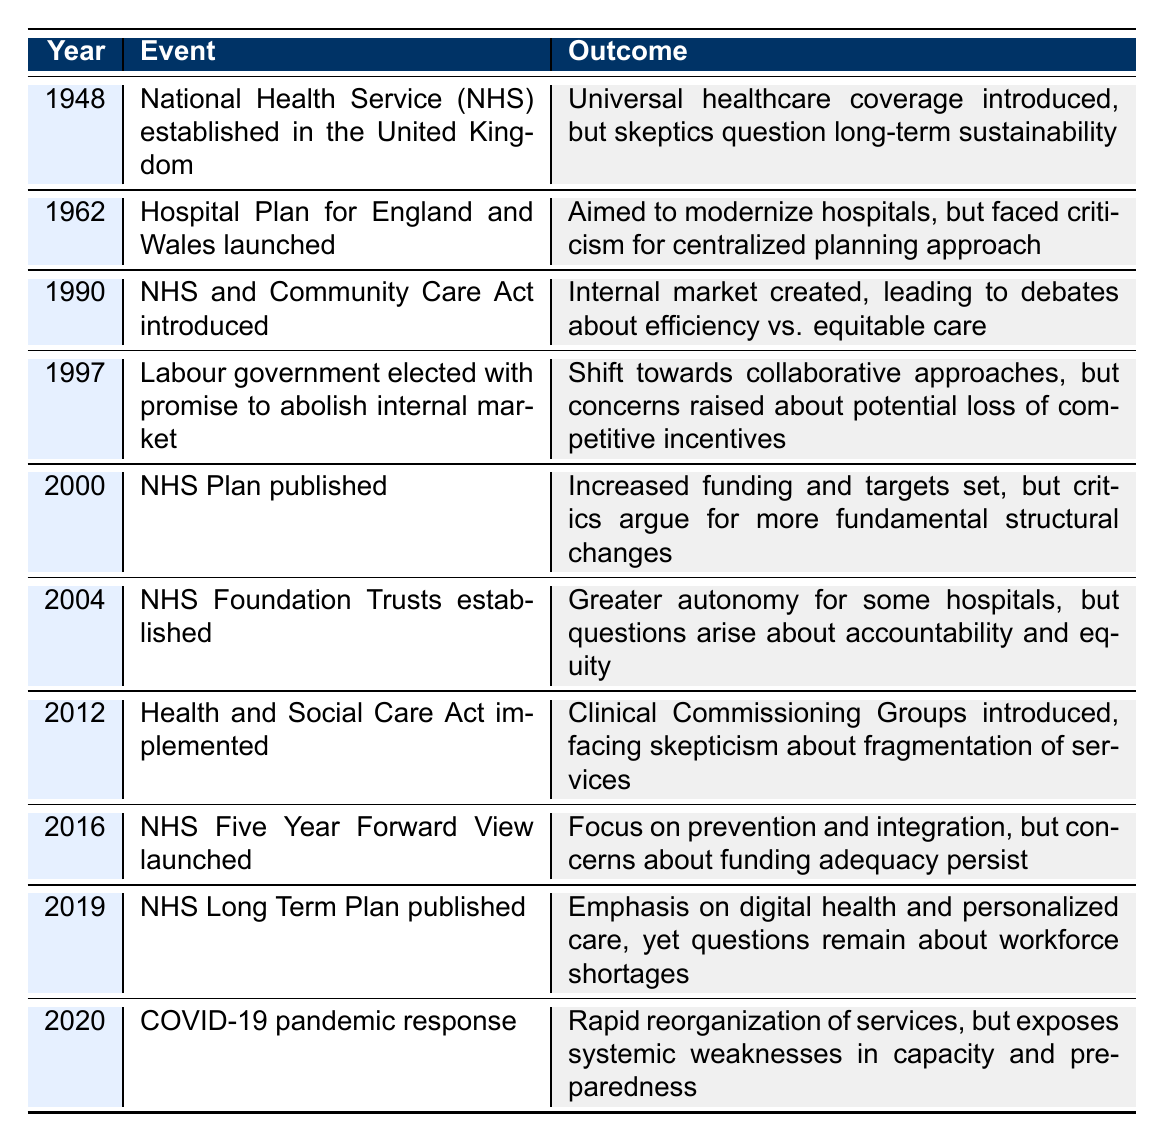What year was the National Health Service established? The table indicates that the National Health Service (NHS) was established in the year 1948.
Answer: 1948 What was the outcome of the 2012 Health and Social Care Act? According to the table, the outcome was the introduction of Clinical Commissioning Groups, with skepticism about the fragmentation of services.
Answer: Fragmentation skepticism In what year did the Labour government promise to abolish the internal market? The table shows that the Labour government made this promise in the year 1997.
Answer: 1997 How many events were aimed at increasing funding or improving healthcare systems? The events that aimed at increasing funding or improving systems are from 2000 (NHS Plan published) and 2016 (NHS Five Year Forward View launched). Thus, there are two events with this aim.
Answer: 2 Is it true that the establishment of NHS Foundation Trusts in 2004 created more accountability? The table suggests that while NHS Foundation Trusts established greater autonomy for some hospitals, questions arose about accountability, which indicates that it is not true that accountability increased.
Answer: No What is the time span from the establishment of the NHS to the publication of the NHS Long Term Plan? The NHS was established in 1948 and the NHS Long Term Plan was published in 2019. Thus, the time span is 2019 - 1948 = 71 years.
Answer: 71 years In which year was there a significant emphasis on digital health and personalized care? The table states that the NHS Long Term Plan, which emphasized digital health and personalized care, was published in 2019.
Answer: 2019 Which event faced criticism for a centralized planning approach, and what year did it occur? The event that faced criticism for a centralized planning approach is the Hospital Plan for England and Wales, which launched in 1962.
Answer: 1962 Based on the outcomes listed, does there seem to be a trend of skepticism towards healthcare reforms over the years? Reviewing the outcomes across the years, each major event has faced some level of skepticism, indicating a consistent trend of skepticism towards reforms.
Answer: Yes 